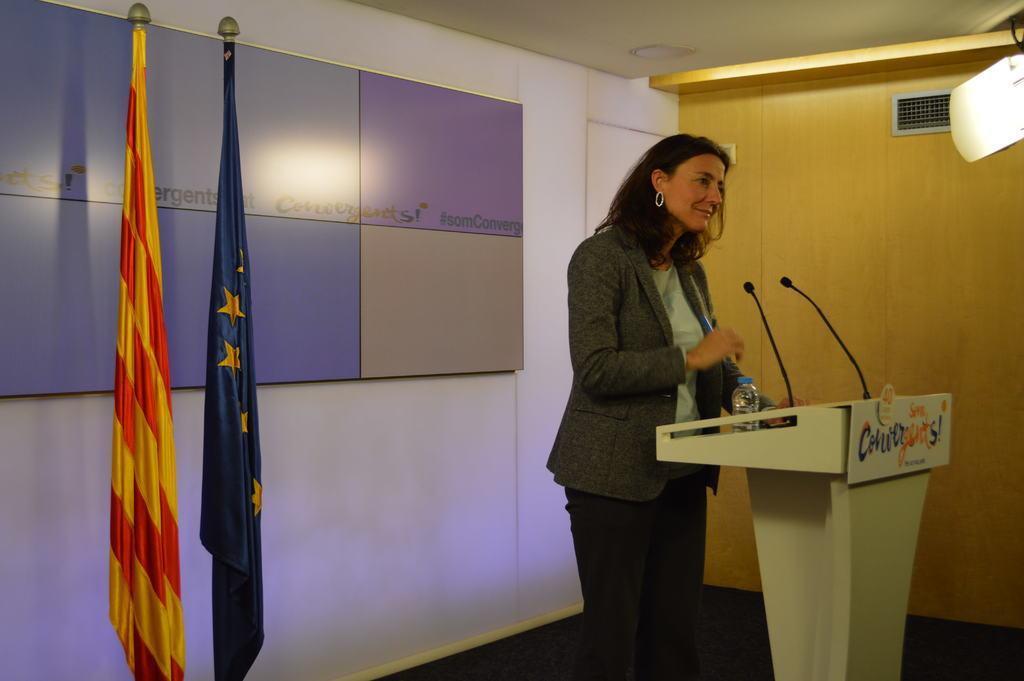In one or two sentences, can you explain what this image depicts? In this image we can see a lady is standing, in front of her there is a podium, on that there are two mics, and a bottle, behind her there is a board with text on it, there are flags, a light, there is a grille on the wall. 